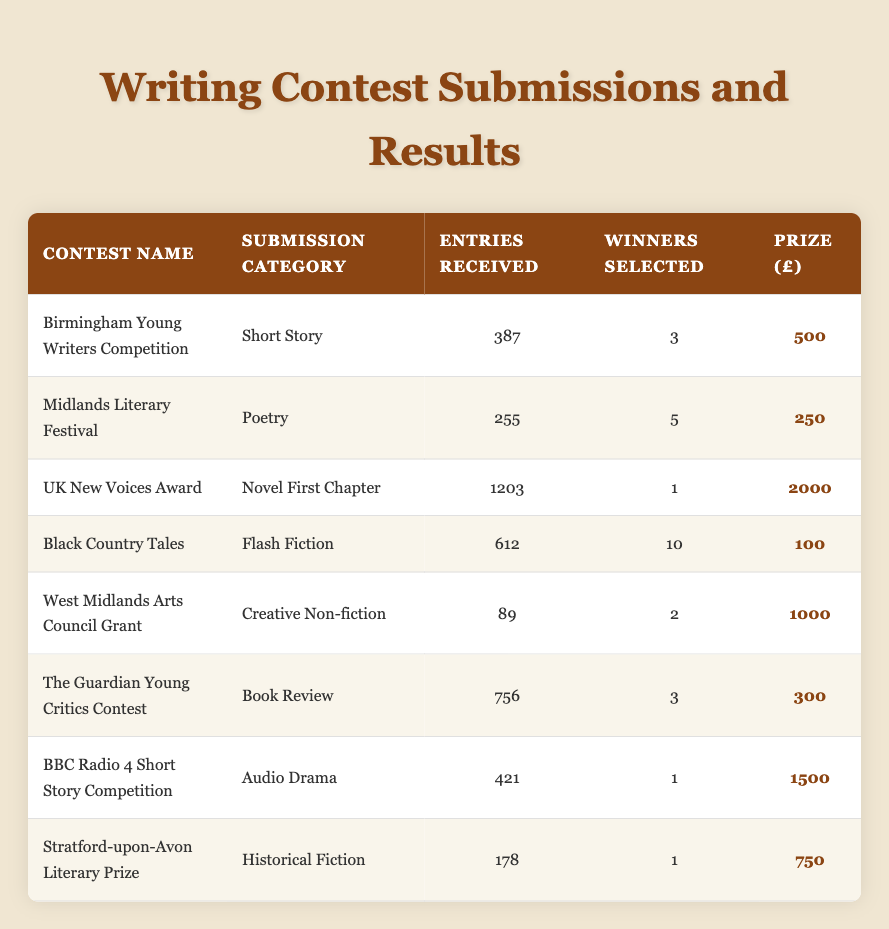What is the highest prize amount listed in the table? Scanning the "Prize (£)" column, the highest amount is 2000, which corresponds to the "UK New Voices Award" for "Novel First Chapter."
Answer: 2000 How many entries were received for the "Black Country Tales" contest? Looking at the "Entries Received" column for the "Black Country Tales," it shows 612 entries.
Answer: 612 Did the "Midlands Literary Festival" have more winners than the "Birmingham Young Writers Competition"? The "Midlands Literary Festival" selected 5 winners, while the "Birmingham Young Writers Competition" selected 3 winners. Since 5 is greater than 3, the answer is yes.
Answer: Yes What is the total number of entries received across all contests? Summing the entries: 387 + 255 + 1203 + 612 + 89 + 756 + 421 + 178 = 3001.
Answer: 3001 Is there a contest that received less than 100 entries? The "West Midlands Arts Council Grant" received 89 entries, which is less than 100. Thus, the answer is yes.
Answer: Yes What is the average prize amount for the contests listed? The total prize amount is calculated as: 500 + 250 + 2000 + 100 + 1000 + 300 + 1500 + 750 = 4600. There are 8 contests, so the average is 4600 / 8 = 575.
Answer: 575 Which contest had the fewest winners selected? By examining the "Winners Selected" column, the "UK New Voices Award" had only 1 winner selected. Thus, it had the fewest winners.
Answer: UK New Voices Award What is the difference in the number of entries received between "The Guardian Young Critics Contest" and "West Midlands Arts Council Grant"? The entries received are 756 for "The Guardian Young Critics Contest" and 89 for the "West Midlands Arts Council Grant." The difference is 756 - 89 = 667.
Answer: 667 